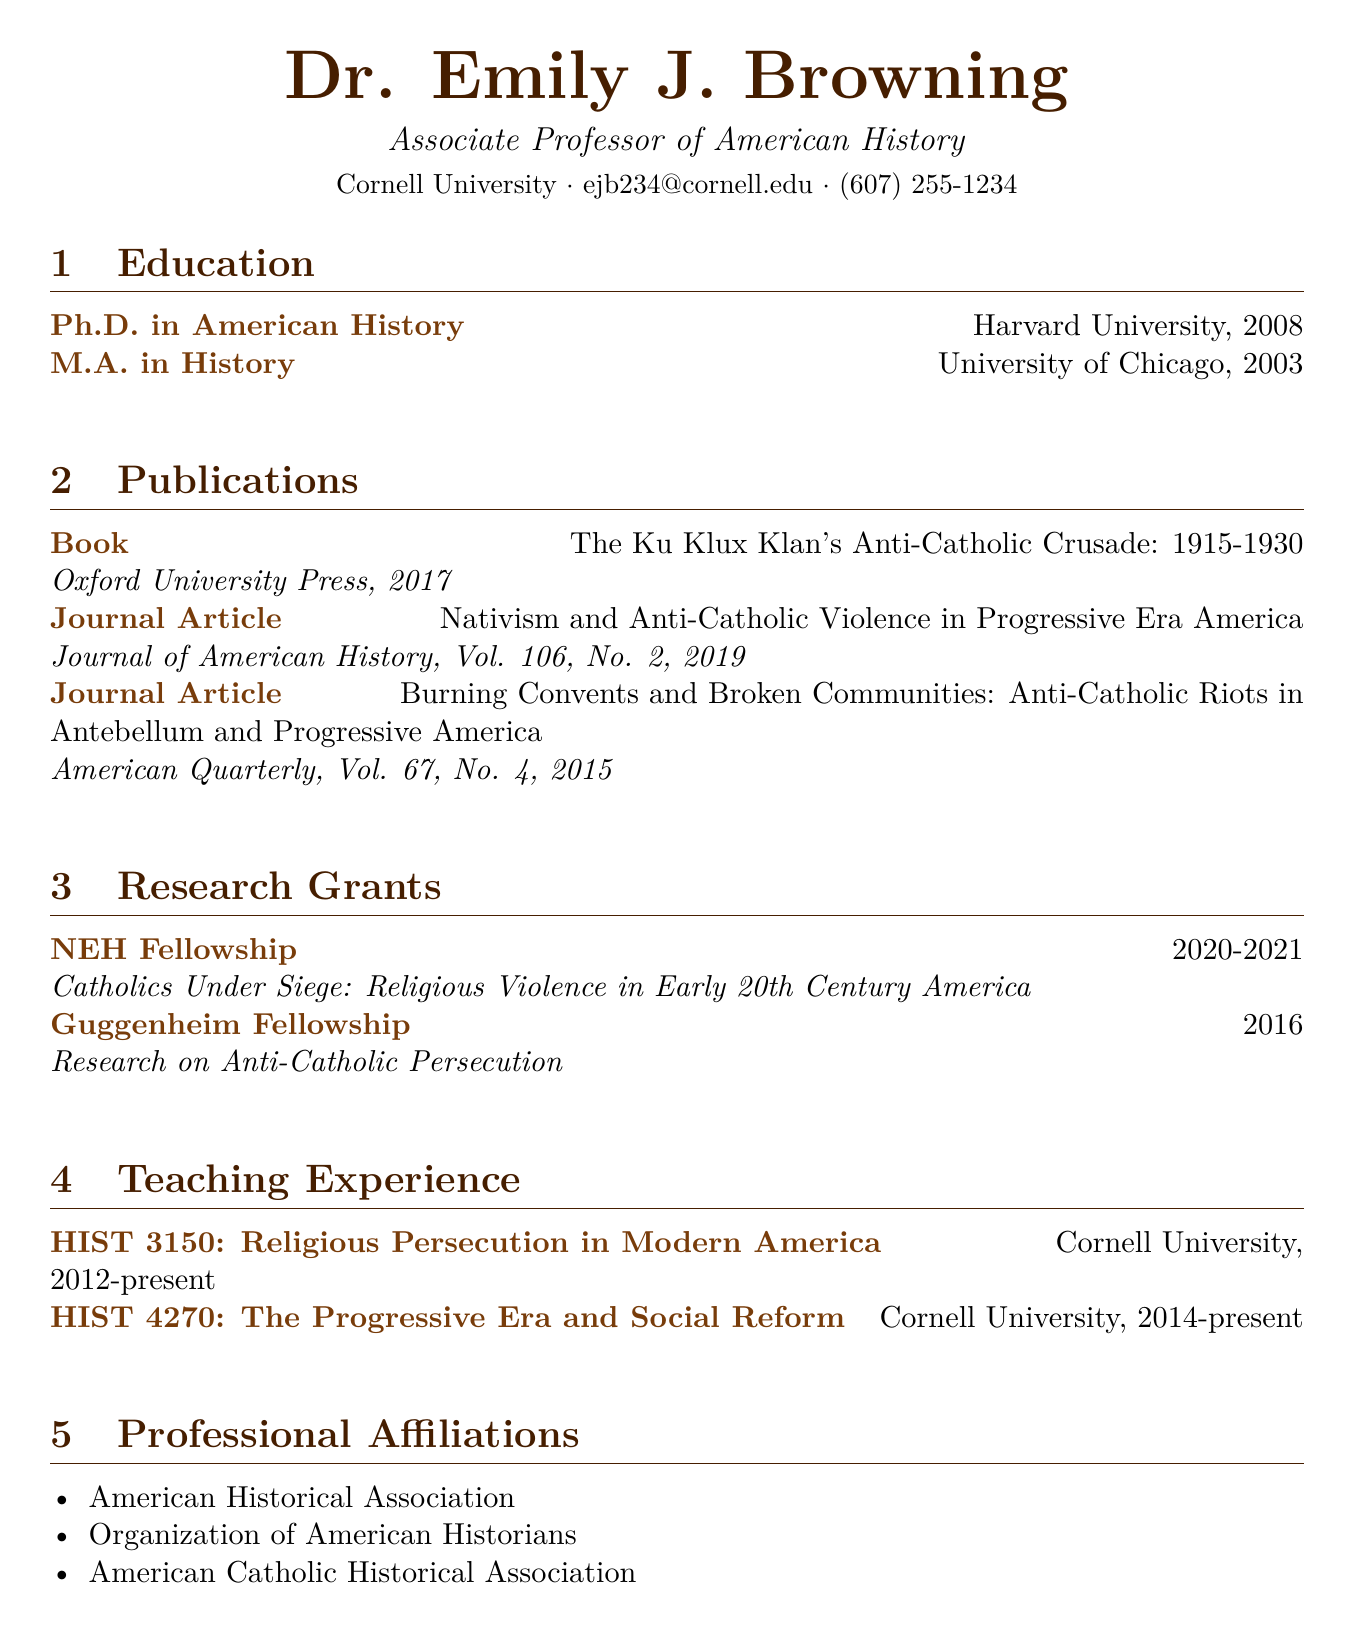What is Dr. Emily J. Browning's current title? The title section lists Dr. Browning's current title as she is an Associate Professor of American History.
Answer: Associate Professor of American History What year did Dr. Browning receive her Ph.D.? The education section specifies that Dr. Browning earned her Ph.D. in American History in 2008.
Answer: 2008 Which publication focuses on the Ku Klux Klan's anti-Catholic activities? Upon reviewing the publication list, "The Ku Klux Klan's Anti-Catholic Crusade: 1915-1930" addresses this topic specifically.
Answer: The Ku Klux Klan's Anti-Catholic Crusade: 1915-1930 What is the name of the journal that published Dr. Browning's article in 2019? The journal section indicates that her article titled "Nativism and Anti-Catholic Violence in Progressive Era America" was published in the Journal of American History.
Answer: Journal of American History How many research grants has Dr. Browning received? The research grants section lists two grants that Dr. Browning has received.
Answer: 2 What course has Dr. Browning been teaching since 2012? The teaching experience section indicates that she has been teaching "HIST 3150: Religious Persecution in Modern America" since 2012.
Answer: HIST 3150: Religious Persecution in Modern America Which university did Dr. Browning attend for her M.A. degree? The education section specifies that the M.A. in History was obtained from the University of Chicago.
Answer: University of Chicago In what year did Dr. Browning receive the Guggenheim Fellowship? The research grants section indicates that the Guggenheim Fellowship was awarded to her in 2016.
Answer: 2016 Which professional organization is Dr. Browning affiliated with? The professional affiliations section lists several organizations, one being the American Historical Association.
Answer: American Historical Association 